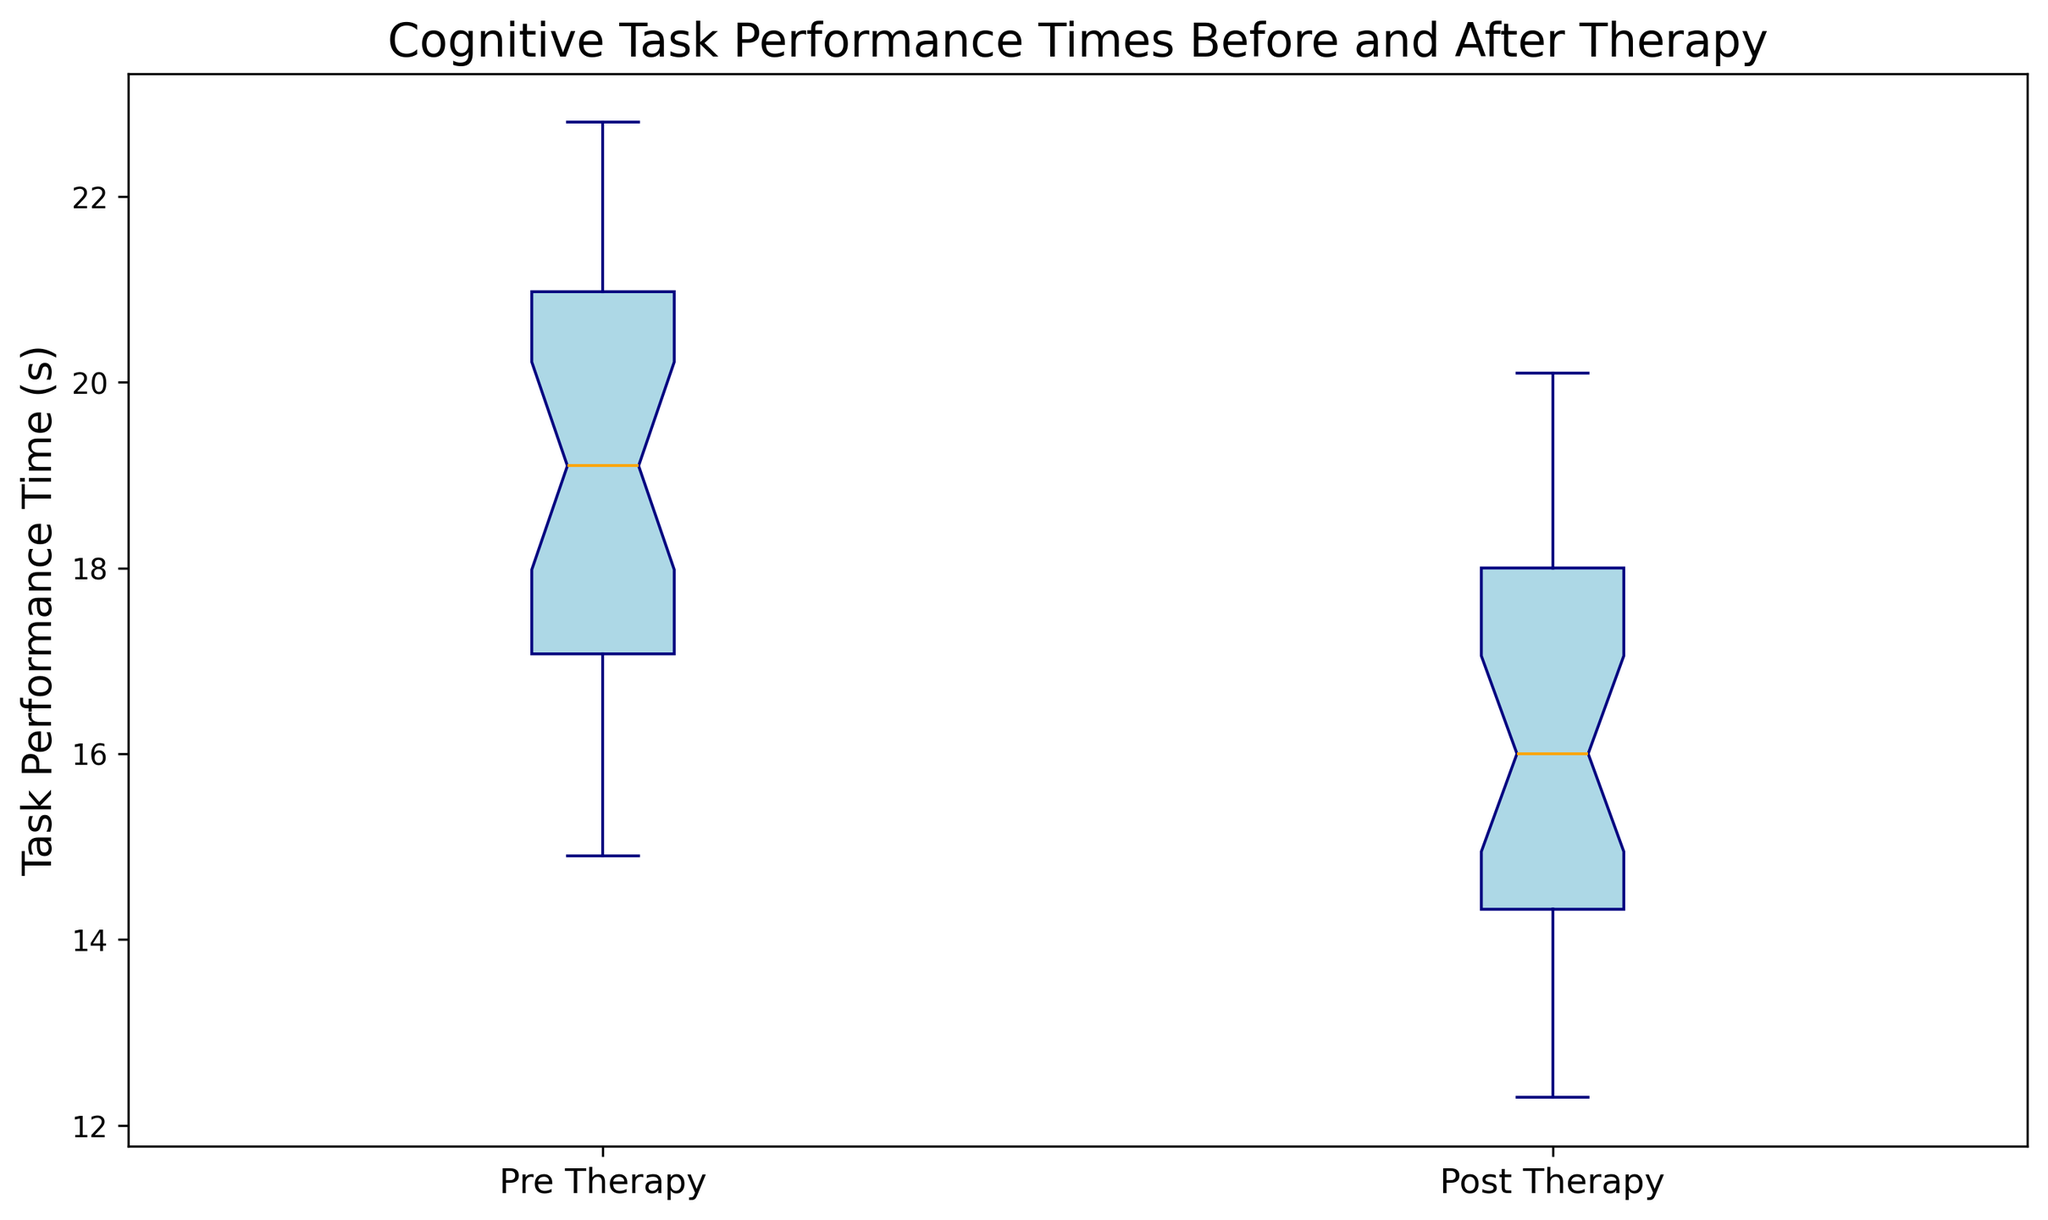What is the median task performance time before therapy? To find the median, we look at the middle value of the Pre Therapy box plot whisker. This value is represented by the line in the center of the box.
Answer: About 19.5 seconds Which therapy condition generally shows lower task performance times, Pre Therapy or Post Therapy? Compare the medians and overall positions of the two box plots. The Post Therapy box plot, which is shifted lower, shows lower task performance times.
Answer: Post Therapy What is the interquartile range (IQR) of the post therapy times? The IQR is the difference between the third quartile (Q3) and the first quartile (Q1) of the Post Therapy box plot. Identify these values from the plot and subtract Q1 from Q3.
Answer: About 4 seconds Are there any outliers in the pre therapy times? Outliers are typically shown as points outside the whiskers of the box plot. Check if there are any such points in the Pre Therapy box plot.
Answer: No How much is the reduction in median task performance time after therapy? Calculate the difference between the medians of Post Therapy and Pre Therapy. This is derived from the difference in the lines representing the medians in each box plot.
Answer: About 3 seconds Which therapy condition shows a more extensive range of task performance times? The range is represented by the length of the whiskers in each box plot. The longer the whiskers, the greater the range.
Answer: Pre Therapy What is the maximum task performance time after therapy? The maximum is represented by the top whisker of the Post Therapy box plot. Identify this value.
Answer: About 20.1 seconds Is the spread (variability) of task performance times greater before or after therapy? The spread is represented by the size of the interquartile range and the variance in whisker lengths. Compare these features in the Pre and Post Therapy box plots.
Answer: Before Therapy What color represents the median in both therapy conditions? The median line in each box plot is distinctly colored. Identify this color.
Answer: Orange Are the task performance times more tightly clustered around the median before or after therapy? A tighter clustering around the median is indicated by a shorter interquartile range (IQR). Compare the IQRs of the two box plots.
Answer: After Therapy 